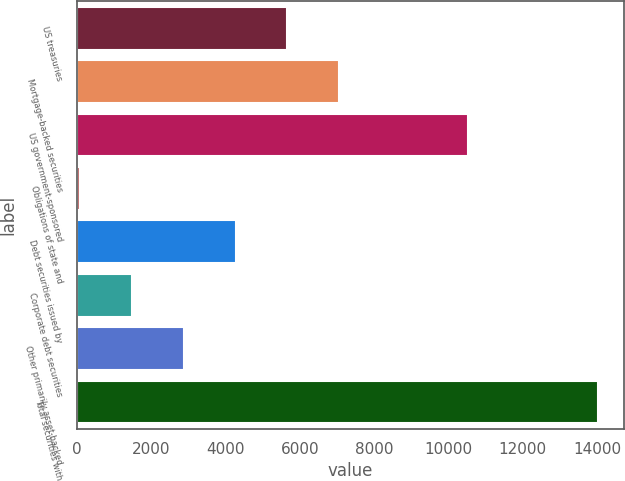Convert chart to OTSL. <chart><loc_0><loc_0><loc_500><loc_500><bar_chart><fcel>US treasuries<fcel>Mortgage-backed securities<fcel>US government-sponsored<fcel>Obligations of state and<fcel>Debt securities issued by<fcel>Corporate debt securities<fcel>Other primarily asset-backed<fcel>Total securities with<nl><fcel>5664.8<fcel>7057<fcel>10525<fcel>96<fcel>4272.6<fcel>1488.2<fcel>2880.4<fcel>14018<nl></chart> 